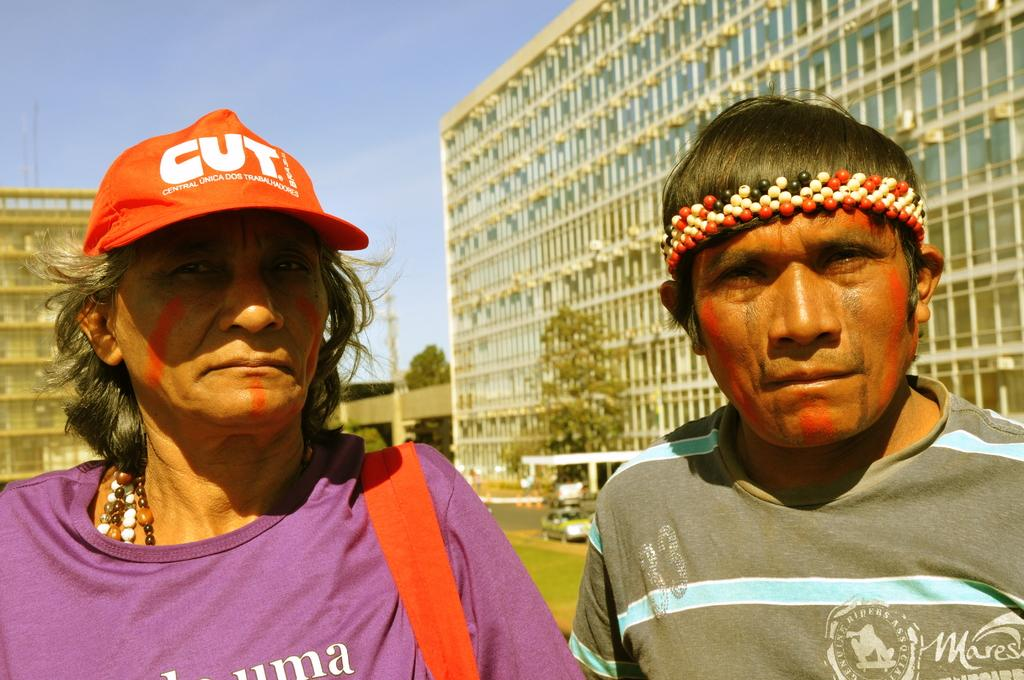How many people are present in the image? There is a man and a woman present in the image. What is the woman wearing on her head? The woman is wearing a cap. What can be seen in the background of the image? There are buildings, trees, and vehicles visible in the background of the image. Can you see any steam coming from the man's ears in the image? There is no steam visible in the image, nor is it mentioned in the provided facts. 